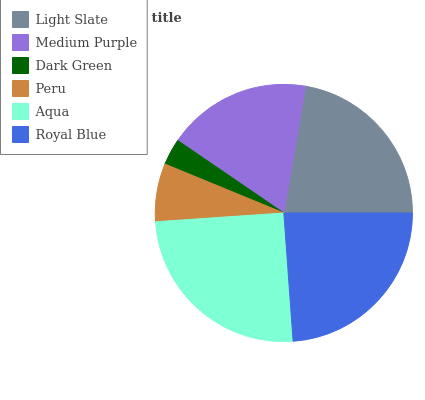Is Dark Green the minimum?
Answer yes or no. Yes. Is Aqua the maximum?
Answer yes or no. Yes. Is Medium Purple the minimum?
Answer yes or no. No. Is Medium Purple the maximum?
Answer yes or no. No. Is Light Slate greater than Medium Purple?
Answer yes or no. Yes. Is Medium Purple less than Light Slate?
Answer yes or no. Yes. Is Medium Purple greater than Light Slate?
Answer yes or no. No. Is Light Slate less than Medium Purple?
Answer yes or no. No. Is Light Slate the high median?
Answer yes or no. Yes. Is Medium Purple the low median?
Answer yes or no. Yes. Is Aqua the high median?
Answer yes or no. No. Is Dark Green the low median?
Answer yes or no. No. 